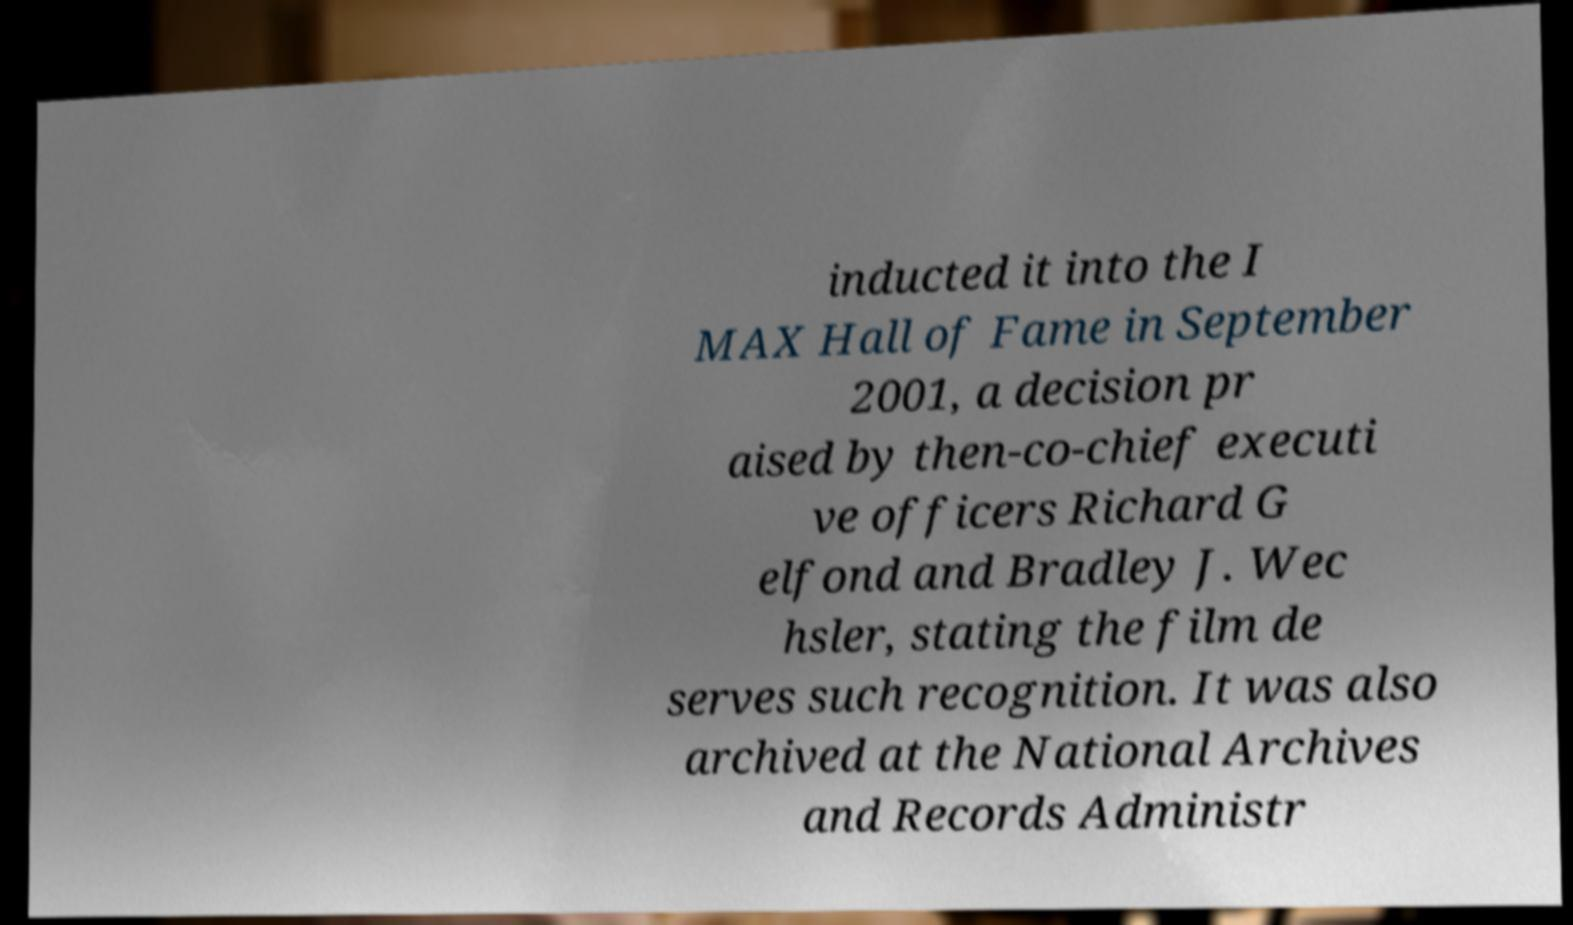Could you assist in decoding the text presented in this image and type it out clearly? inducted it into the I MAX Hall of Fame in September 2001, a decision pr aised by then-co-chief executi ve officers Richard G elfond and Bradley J. Wec hsler, stating the film de serves such recognition. It was also archived at the National Archives and Records Administr 